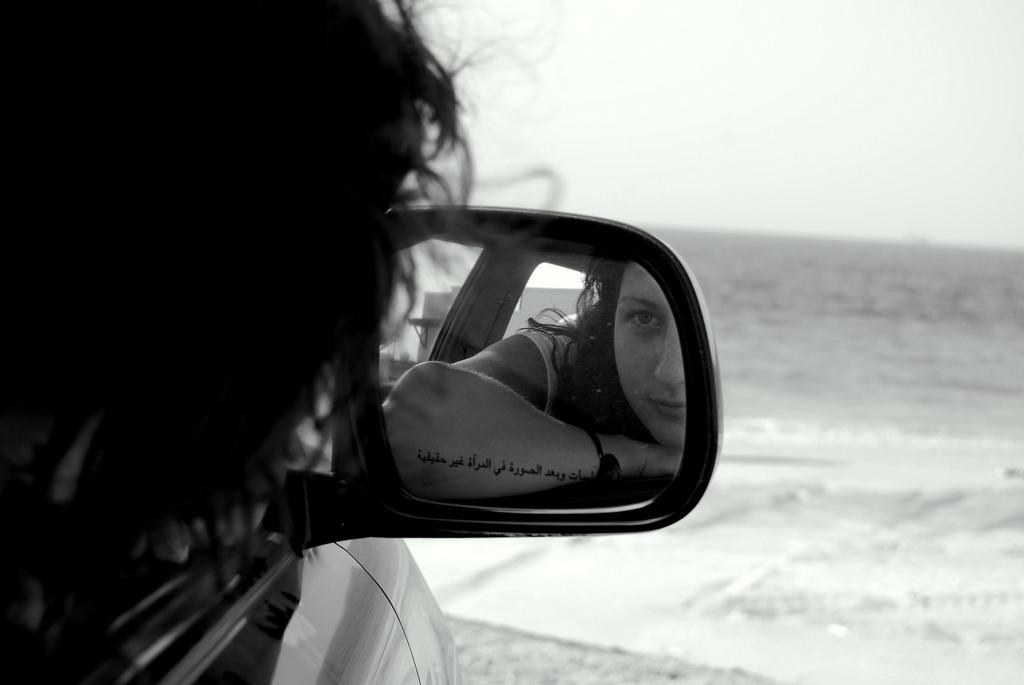Who is present in the image? There is a woman in the picture. What is the woman doing in the image? The woman is looking in the mirror of a car. What can be seen in the background of the image? There is a water body in the background of the image. How would you describe the weather in the image? The sky is clear in the image, suggesting good weather. What type of bat can be seen flying in the image? There is no bat present in the image; it features a woman looking in the mirror of a car with a water body in the background. How does the beggar interact with the woman in the image? There is no beggar present in the image; it only features a woman looking in the mirror of a car. 